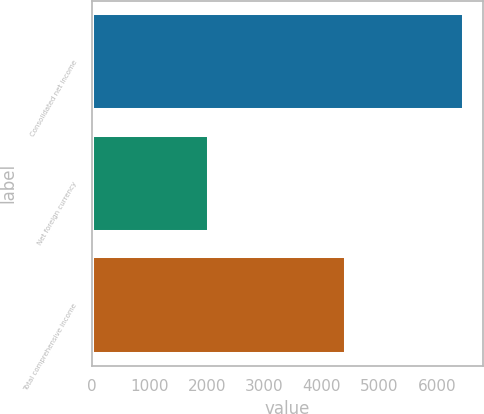Convert chart. <chart><loc_0><loc_0><loc_500><loc_500><bar_chart><fcel>Consolidated net income<fcel>Net foreign currency<fcel>Total comprehensive income<nl><fcel>6476<fcel>2035<fcel>4429<nl></chart> 